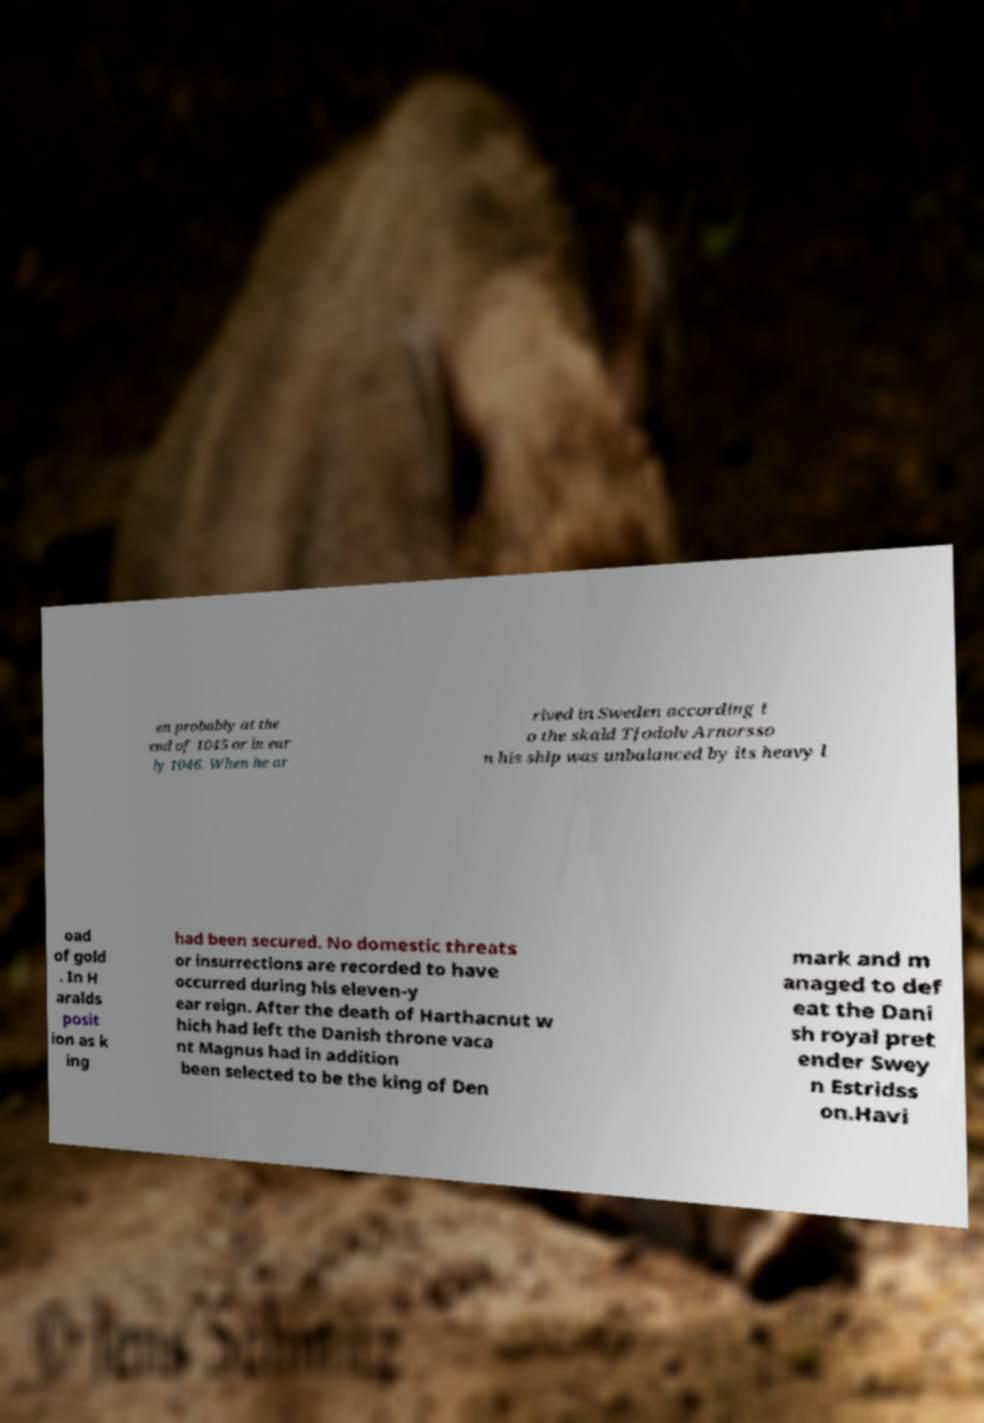Could you extract and type out the text from this image? en probably at the end of 1045 or in ear ly 1046. When he ar rived in Sweden according t o the skald Tjodolv Arnorsso n his ship was unbalanced by its heavy l oad of gold . In H aralds posit ion as k ing had been secured. No domestic threats or insurrections are recorded to have occurred during his eleven-y ear reign. After the death of Harthacnut w hich had left the Danish throne vaca nt Magnus had in addition been selected to be the king of Den mark and m anaged to def eat the Dani sh royal pret ender Swey n Estridss on.Havi 